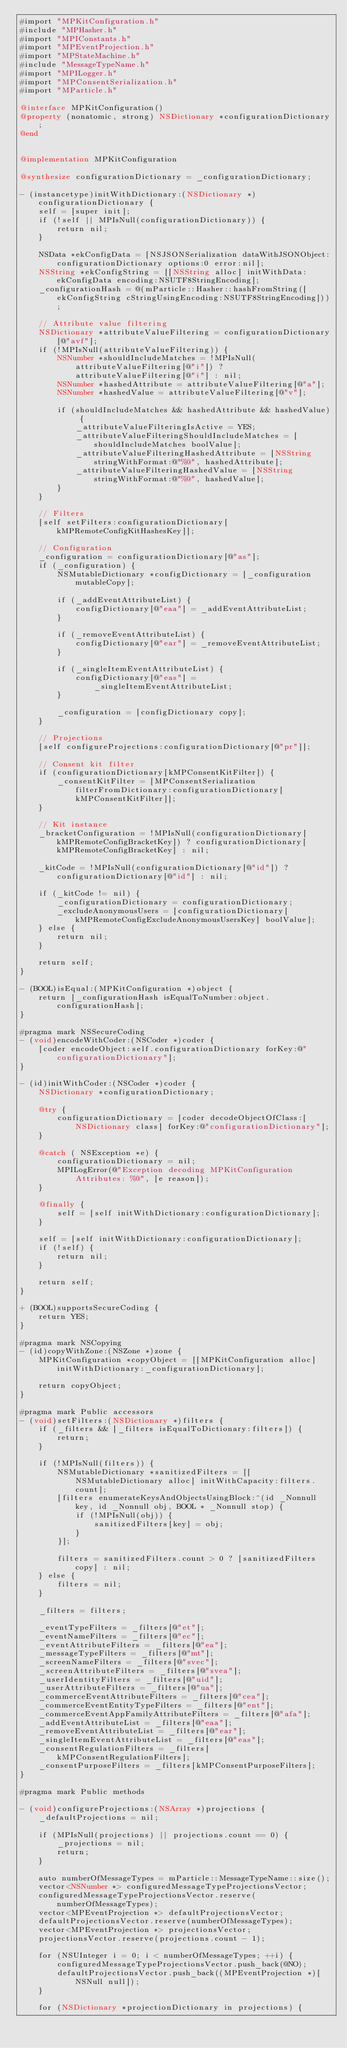<code> <loc_0><loc_0><loc_500><loc_500><_ObjectiveC_>#import "MPKitConfiguration.h"
#include "MPHasher.h"
#import "MPIConstants.h"
#import "MPEventProjection.h"
#import "MPStateMachine.h"
#include "MessageTypeName.h"
#import "MPILogger.h"
#import "MPConsentSerialization.h"
#import "MParticle.h"

@interface MPKitConfiguration()
@property (nonatomic, strong) NSDictionary *configurationDictionary;
@end


@implementation MPKitConfiguration

@synthesize configurationDictionary = _configurationDictionary;

- (instancetype)initWithDictionary:(NSDictionary *)configurationDictionary {
    self = [super init];
    if (!self || MPIsNull(configurationDictionary)) {
        return nil;
    }
    
    NSData *ekConfigData = [NSJSONSerialization dataWithJSONObject:configurationDictionary options:0 error:nil];
    NSString *ekConfigString = [[NSString alloc] initWithData:ekConfigData encoding:NSUTF8StringEncoding];
    _configurationHash = @(mParticle::Hasher::hashFromString([ekConfigString cStringUsingEncoding:NSUTF8StringEncoding]));
    
    // Attribute value filtering
    NSDictionary *attributeValueFiltering = configurationDictionary[@"avf"];
    if (!MPIsNull(attributeValueFiltering)) {
        NSNumber *shouldIncludeMatches = !MPIsNull(attributeValueFiltering[@"i"]) ? attributeValueFiltering[@"i"] : nil;
        NSNumber *hashedAttribute = attributeValueFiltering[@"a"];
        NSNumber *hashedValue = attributeValueFiltering[@"v"];
        
        if (shouldIncludeMatches && hashedAttribute && hashedValue) {
            _attributeValueFilteringIsActive = YES;
            _attributeValueFilteringShouldIncludeMatches = [shouldIncludeMatches boolValue];
            _attributeValueFilteringHashedAttribute = [NSString stringWithFormat:@"%@", hashedAttribute];
            _attributeValueFilteringHashedValue = [NSString stringWithFormat:@"%@", hashedValue];
        }
    }
    
    // Filters
    [self setFilters:configurationDictionary[kMPRemoteConfigKitHashesKey]];
    
    // Configuration
    _configuration = configurationDictionary[@"as"];
    if (_configuration) {
        NSMutableDictionary *configDictionary = [_configuration mutableCopy];
        
        if (_addEventAttributeList) {
            configDictionary[@"eaa"] = _addEventAttributeList;
        }
        
        if (_removeEventAttributeList) {
            configDictionary[@"ear"] = _removeEventAttributeList;
        }
        
        if (_singleItemEventAttributeList) {
            configDictionary[@"eas"] = _singleItemEventAttributeList;
        }
        
        _configuration = [configDictionary copy];
    }
    
    // Projections
    [self configureProjections:configurationDictionary[@"pr"]];
    
    // Consent kit filter
    if (configurationDictionary[kMPConsentKitFilter]) {
        _consentKitFilter = [MPConsentSerialization filterFromDictionary:configurationDictionary[kMPConsentKitFilter]];
    }
    
    // Kit instance
    _bracketConfiguration = !MPIsNull(configurationDictionary[kMPRemoteConfigBracketKey]) ? configurationDictionary[kMPRemoteConfigBracketKey] : nil;
    
    _kitCode = !MPIsNull(configurationDictionary[@"id"]) ? configurationDictionary[@"id"] : nil;
    
    if (_kitCode != nil) {
        _configurationDictionary = configurationDictionary;
        _excludeAnonymousUsers = [configurationDictionary[kMPRemoteConfigExcludeAnonymousUsersKey] boolValue];
    } else {
        return nil;
    }
    
    return self;
}

- (BOOL)isEqual:(MPKitConfiguration *)object {
    return [_configurationHash isEqualToNumber:object.configurationHash];
}

#pragma mark NSSecureCoding
- (void)encodeWithCoder:(NSCoder *)coder {
    [coder encodeObject:self.configurationDictionary forKey:@"configurationDictionary"];
}

- (id)initWithCoder:(NSCoder *)coder {
    NSDictionary *configurationDictionary;
    
    @try {
        configurationDictionary = [coder decodeObjectOfClass:[NSDictionary class] forKey:@"configurationDictionary"];
    }
    
    @catch ( NSException *e) {
        configurationDictionary = nil;
        MPILogError(@"Exception decoding MPKitConfiguration Attributes: %@", [e reason]);
    }
    
    @finally {
        self = [self initWithDictionary:configurationDictionary];
    }
    
    self = [self initWithDictionary:configurationDictionary];
    if (!self) {
        return nil;
    }
    
    return self;
}

+ (BOOL)supportsSecureCoding {
    return YES;
}

#pragma mark NSCopying
- (id)copyWithZone:(NSZone *)zone {
    MPKitConfiguration *copyObject = [[MPKitConfiguration alloc] initWithDictionary:_configurationDictionary];

    return copyObject;
}

#pragma mark Public accessors
- (void)setFilters:(NSDictionary *)filters {
    if (_filters && [_filters isEqualToDictionary:filters]) {
        return;
    }
    
    if (!MPIsNull(filters)) {
        NSMutableDictionary *sanitizedFilters = [[NSMutableDictionary alloc] initWithCapacity:filters.count];
        [filters enumerateKeysAndObjectsUsingBlock:^(id _Nonnull key, id _Nonnull obj, BOOL * _Nonnull stop) {
            if (!MPIsNull(obj)) {
                sanitizedFilters[key] = obj;
            }
        }];
        
        filters = sanitizedFilters.count > 0 ? [sanitizedFilters copy] : nil;
    } else {
        filters = nil;
    }
    
    _filters = filters;
    
    _eventTypeFilters = _filters[@"et"];
    _eventNameFilters = _filters[@"ec"];
    _eventAttributeFilters = _filters[@"ea"];
    _messageTypeFilters = _filters[@"mt"];
    _screenNameFilters = _filters[@"svec"];
    _screenAttributeFilters = _filters[@"svea"];
    _userIdentityFilters = _filters[@"uid"];
    _userAttributeFilters = _filters[@"ua"];
    _commerceEventAttributeFilters = _filters[@"cea"];
    _commerceEventEntityTypeFilters = _filters[@"ent"];
    _commerceEventAppFamilyAttributeFilters = _filters[@"afa"];
    _addEventAttributeList = _filters[@"eaa"];
    _removeEventAttributeList = _filters[@"ear"];
    _singleItemEventAttributeList = _filters[@"eas"];
    _consentRegulationFilters = _filters[kMPConsentRegulationFilters];
    _consentPurposeFilters = _filters[kMPConsentPurposeFilters];
}

#pragma mark Public methods

- (void)configureProjections:(NSArray *)projections {
    _defaultProjections = nil;
    
    if (MPIsNull(projections) || projections.count == 0) {
        _projections = nil;
        return;
    }
    
    auto numberOfMessageTypes = mParticle::MessageTypeName::size();
    vector<NSNumber *> configuredMessageTypeProjectionsVector;
    configuredMessageTypeProjectionsVector.reserve(numberOfMessageTypes);
    vector<MPEventProjection *> defaultProjectionsVector;
    defaultProjectionsVector.reserve(numberOfMessageTypes);
    vector<MPEventProjection *> projectionsVector;
    projectionsVector.reserve(projections.count - 1);
    
    for (NSUInteger i = 0; i < numberOfMessageTypes; ++i) {
        configuredMessageTypeProjectionsVector.push_back(@NO);
        defaultProjectionsVector.push_back((MPEventProjection *)[NSNull null]);
    }
    
    for (NSDictionary *projectionDictionary in projections) {</code> 